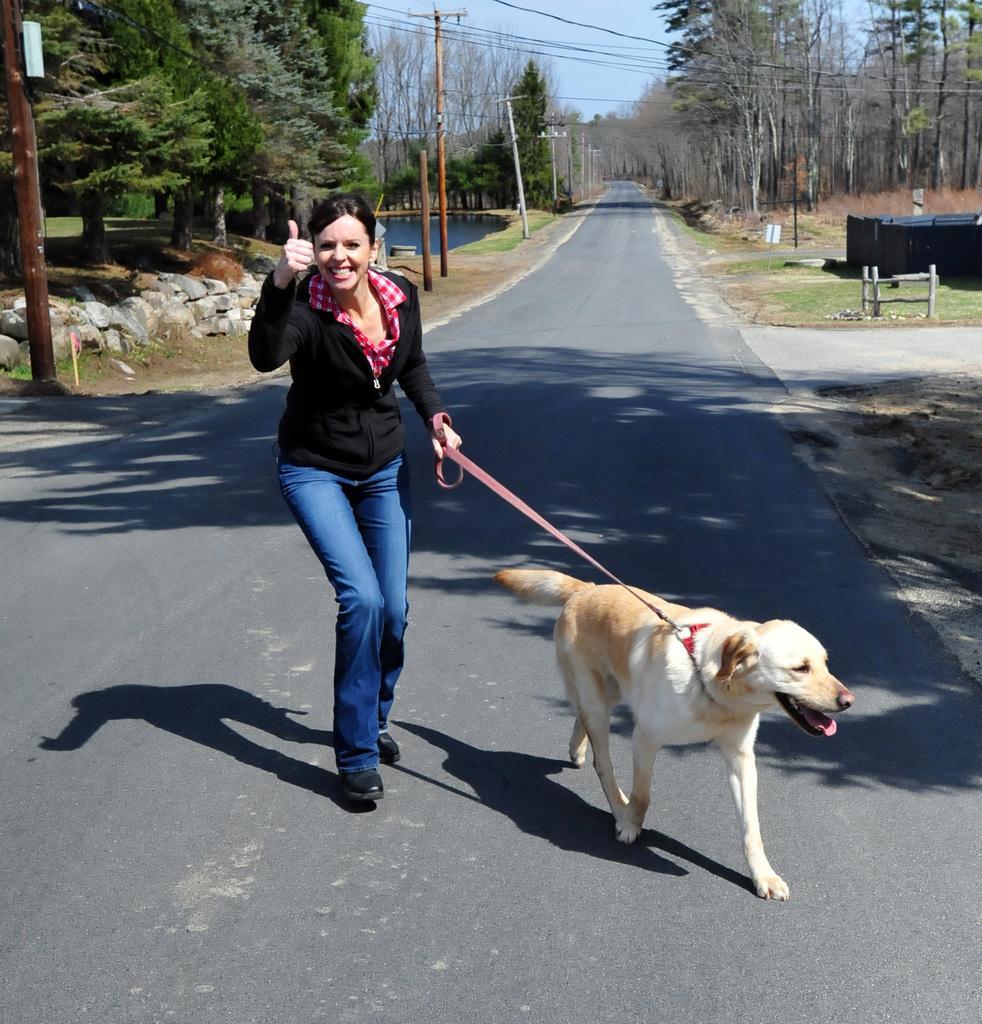Could you give a brief overview of what you see in this image? A woman is holding dogs belt which is tied to a dog. They are on the road. In the background there are trees,poles and sky and water. 